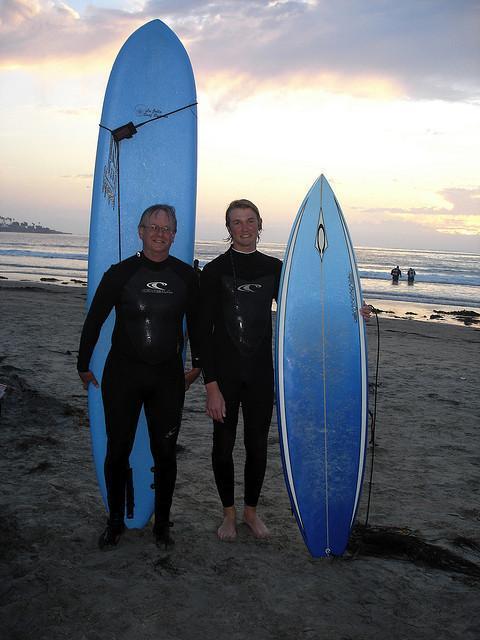How many surfboards are in the picture?
Give a very brief answer. 2. How many people are there?
Give a very brief answer. 2. 